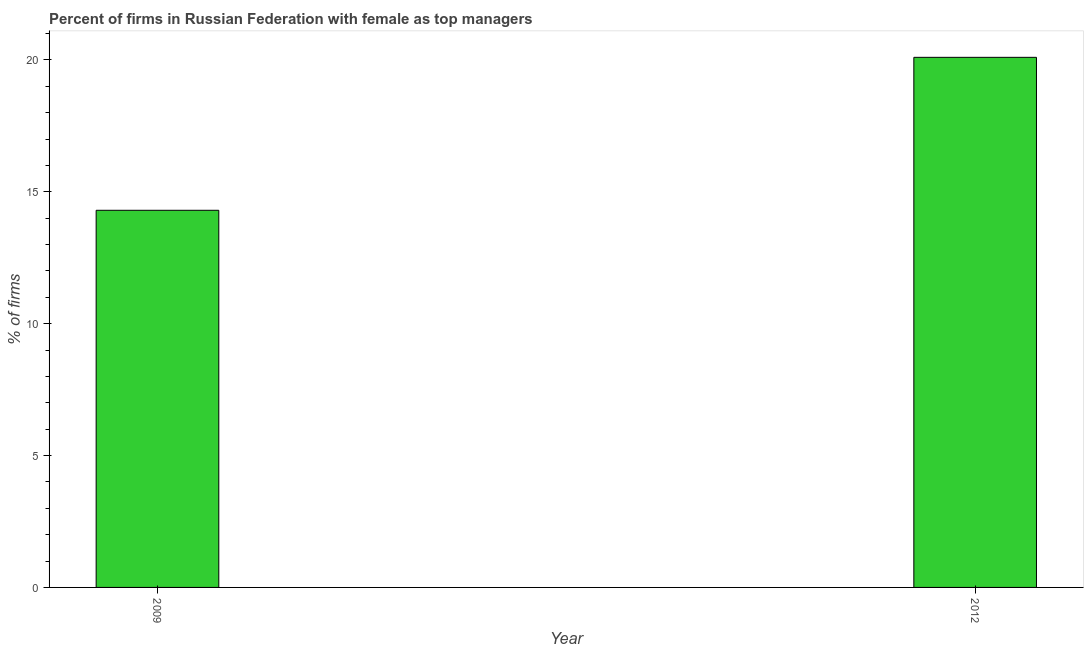Does the graph contain any zero values?
Ensure brevity in your answer.  No. What is the title of the graph?
Provide a succinct answer. Percent of firms in Russian Federation with female as top managers. What is the label or title of the Y-axis?
Provide a succinct answer. % of firms. What is the percentage of firms with female as top manager in 2012?
Keep it short and to the point. 20.1. Across all years, what is the maximum percentage of firms with female as top manager?
Give a very brief answer. 20.1. Across all years, what is the minimum percentage of firms with female as top manager?
Your answer should be very brief. 14.3. In which year was the percentage of firms with female as top manager maximum?
Your answer should be very brief. 2012. In which year was the percentage of firms with female as top manager minimum?
Your response must be concise. 2009. What is the sum of the percentage of firms with female as top manager?
Your response must be concise. 34.4. What is the median percentage of firms with female as top manager?
Ensure brevity in your answer.  17.2. In how many years, is the percentage of firms with female as top manager greater than 5 %?
Provide a succinct answer. 2. What is the ratio of the percentage of firms with female as top manager in 2009 to that in 2012?
Make the answer very short. 0.71. In how many years, is the percentage of firms with female as top manager greater than the average percentage of firms with female as top manager taken over all years?
Give a very brief answer. 1. How many bars are there?
Provide a succinct answer. 2. How many years are there in the graph?
Provide a short and direct response. 2. Are the values on the major ticks of Y-axis written in scientific E-notation?
Offer a very short reply. No. What is the % of firms of 2012?
Your answer should be very brief. 20.1. What is the difference between the % of firms in 2009 and 2012?
Your response must be concise. -5.8. What is the ratio of the % of firms in 2009 to that in 2012?
Make the answer very short. 0.71. 